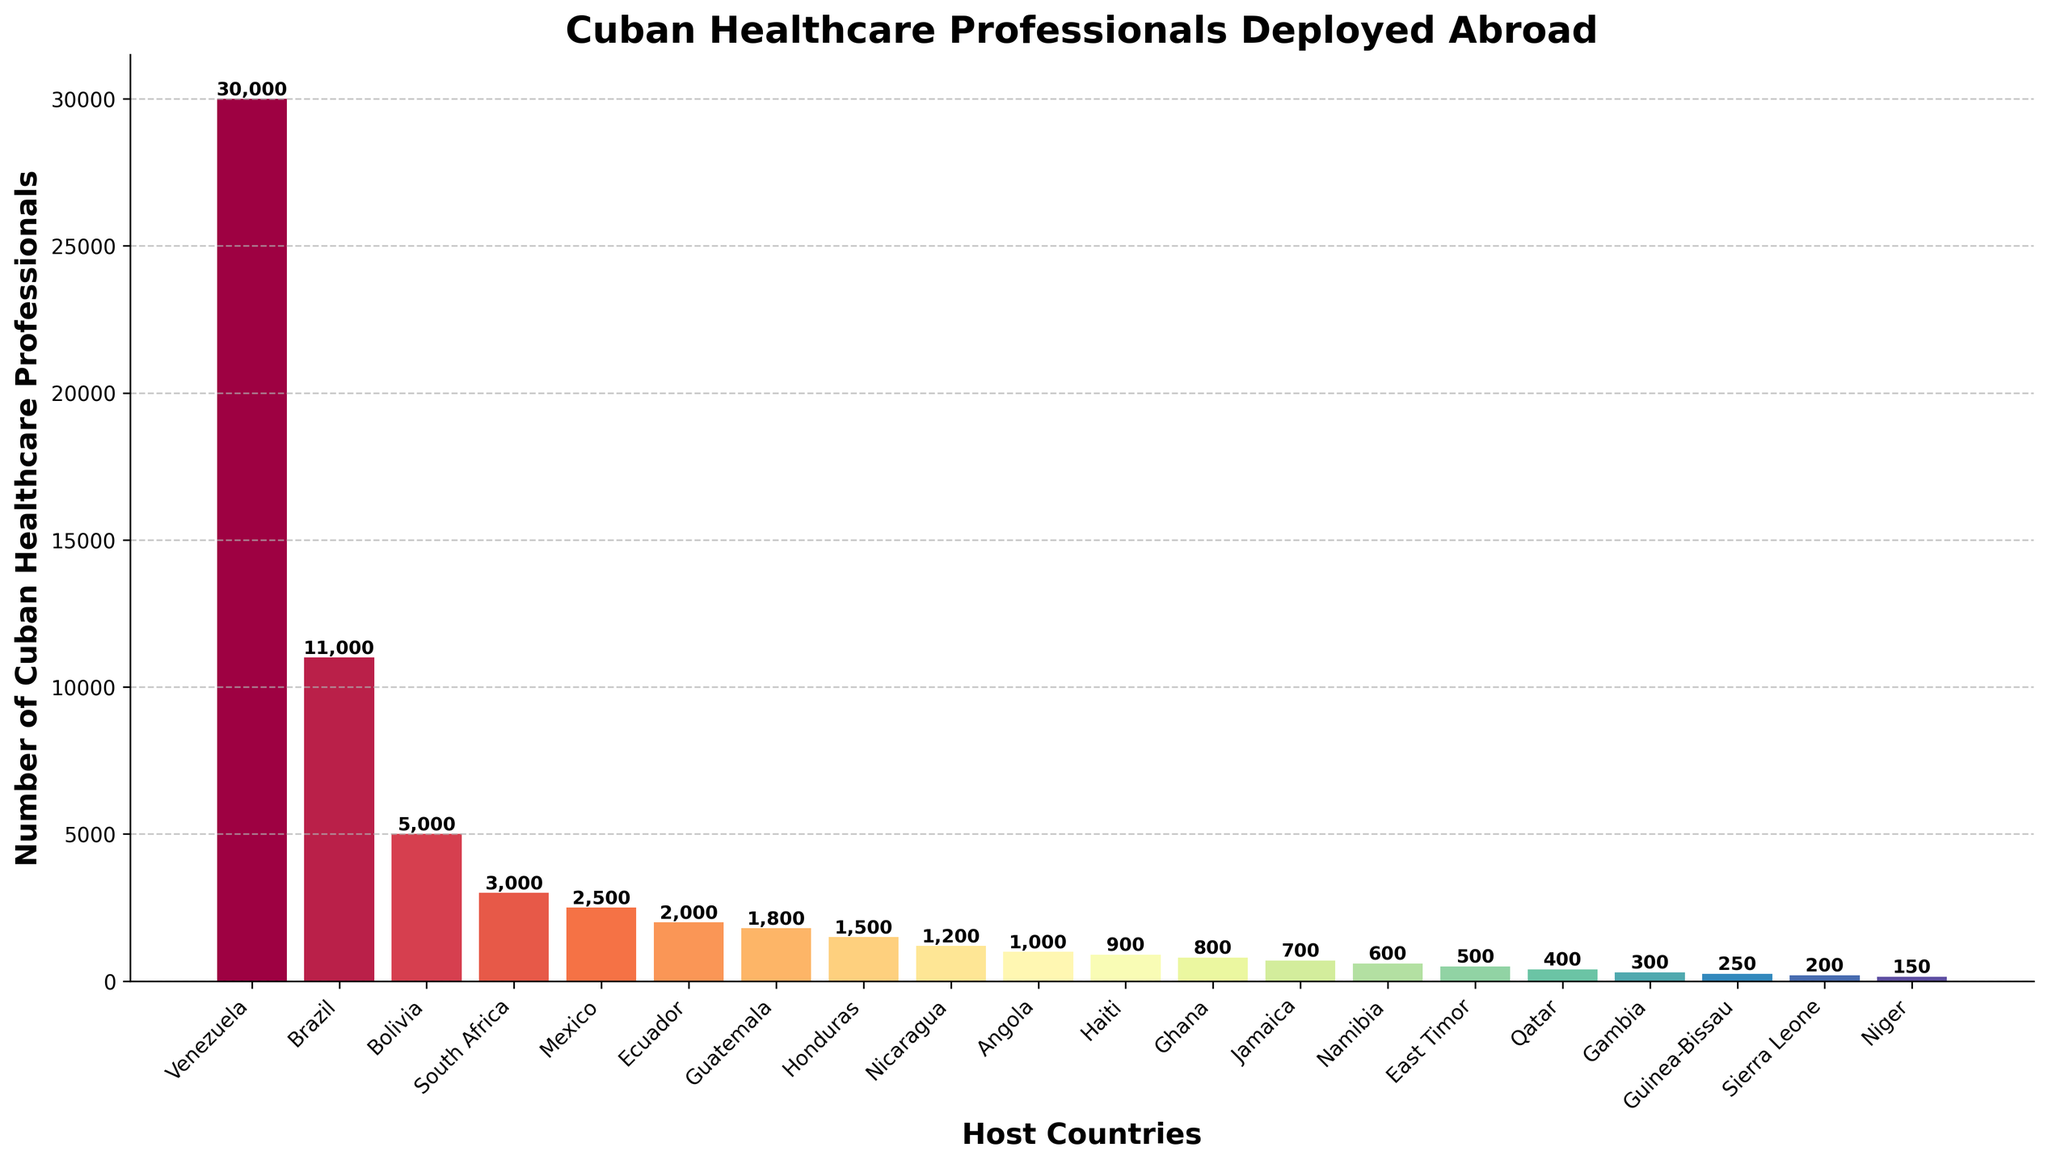Which country has the highest number of Cuban healthcare professionals? The height of the bar representing Venezuela is the tallest among all the bars, indicating it has the highest number of Cuban healthcare professionals.
Answer: Venezuela What is the total number of Cuban healthcare professionals deployed to Brazil and Bolivia? The bars for Brazil and Bolivia show 11,000 and 5,000 Cuban healthcare professionals respectively. Adding these two numbers gives 11,000 + 5,000 = 16,000.
Answer: 16,000 Which country has fewer Cuban healthcare professionals deployed, Nicaragua or Angola? The height of the bars representing Nicaragua and Angola show 1,200 and 1,000 Cuban healthcare professionals respectively. Comparing these, Angola has fewer professionals deployed.
Answer: Angola How many more Cuban healthcare professionals are deployed to South Africa compared to Haiti? South Africa has 3,000 professionals while Haiti has 900. The difference is 3,000 - 900 = 2,100.
Answer: 2,100 What is the average number of Cuban healthcare professionals deployed among the top four countries? The top four countries are Venezuela, Brazil, Bolivia, and South Africa with 30,000, 11,000, 5,000, and 3,000 professionals respectively. The sum is 30,000 + 11,000 + 5,000 + 3,000 = 49,000. Dividing by four gives 49,000 / 4 = 12,250.
Answer: 12,250 Which country hosts Cuban healthcare professionals in numbers closest to 1,500? Both Honduras and Haiti are close, but Honduras has precisely 1,500 Cuban healthcare professionals.
Answer: Honduras What is the combined total of Cuban healthcare professionals deployed to all African countries listed in the data? The African countries listed (South Africa, Angola, Ghana, Namibia, Gambia, Guinea-Bissau, Sierra Leone, Niger) have 3,000, 1,000, 800, 600, 300, 250, 200, and 150 professionals respectively. Adding these numbers gives 3,000 + 1,000 + 800 + 600 + 300 + 250 + 200 + 150 = 6,300.
Answer: 6,300 Identify the countries with fewer than 1,000 Cuban healthcare professionals. The bars that are shorter than the 1,000-mark threshold represent Qatar, Gambia, Guinea-Bissau, Sierra Leone, and Niger. These countries have fewer than 1,000 professionals.
Answer: Qatar, Gambia, Guinea-Bissau, Sierra Leone, Niger 